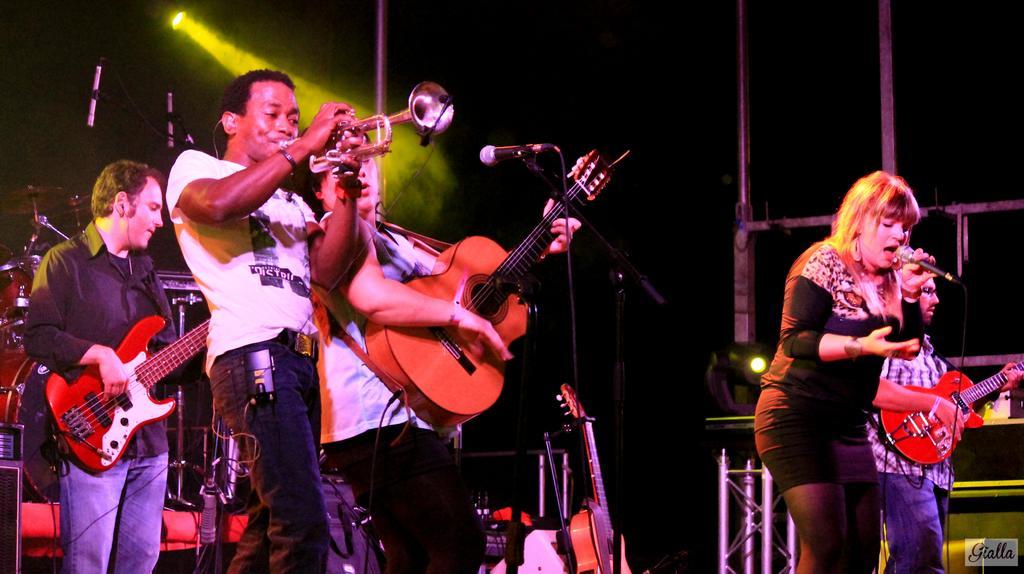Describe this image in one or two sentences. This is the picture of four people on stage and playing some musical instruments and behind them there are some musical instruments and guitars and also there is a yellow light. 